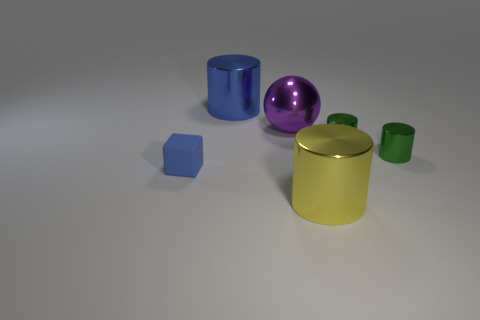What number of other objects are there of the same shape as the blue matte object?
Your answer should be very brief. 0. What shape is the large purple metallic object left of the large metallic object in front of the tiny object that is to the left of the large blue shiny object?
Your answer should be very brief. Sphere. How many balls are metallic things or big cyan matte objects?
Provide a short and direct response. 1. There is a metallic cylinder that is in front of the blue rubber block; is there a object on the left side of it?
Keep it short and to the point. Yes. Are there any other things that have the same material as the blue block?
Make the answer very short. No. There is a blue shiny object; is its shape the same as the big object in front of the small block?
Offer a very short reply. Yes. What number of green objects are either big things or large spheres?
Your answer should be compact. 0. How many metallic cylinders are left of the big purple metal ball and right of the large yellow metallic cylinder?
Give a very brief answer. 0. What material is the small thing that is to the left of the large metallic cylinder behind the big metallic cylinder right of the purple shiny ball made of?
Offer a terse response. Rubber. How many tiny green objects have the same material as the yellow object?
Your answer should be very brief. 2. 